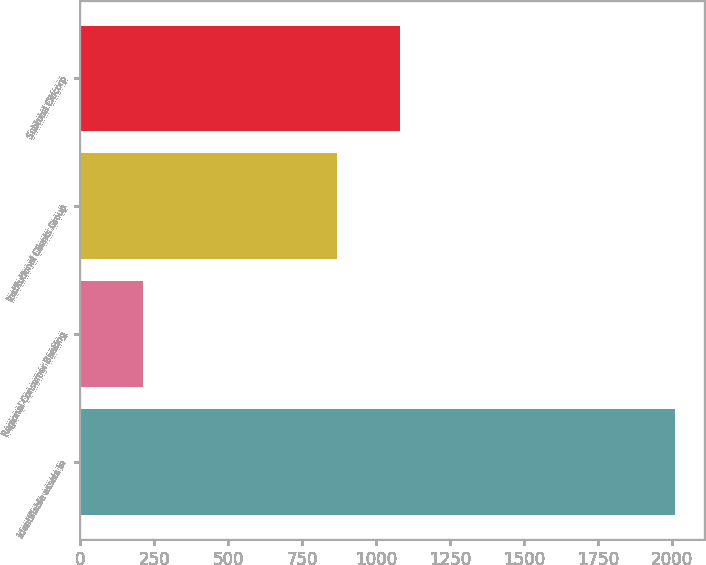Convert chart. <chart><loc_0><loc_0><loc_500><loc_500><bar_chart><fcel>identifiable assets in<fcel>Regional Consumer Banking<fcel>Institutional Clients Group<fcel>Subtotal Citicorp<nl><fcel>2009<fcel>213<fcel>866<fcel>1079<nl></chart> 